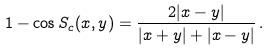<formula> <loc_0><loc_0><loc_500><loc_500>1 - \cos S _ { c } ( x , y ) = \frac { 2 | x - y | } { | x + y | + | x - y | } \, .</formula> 